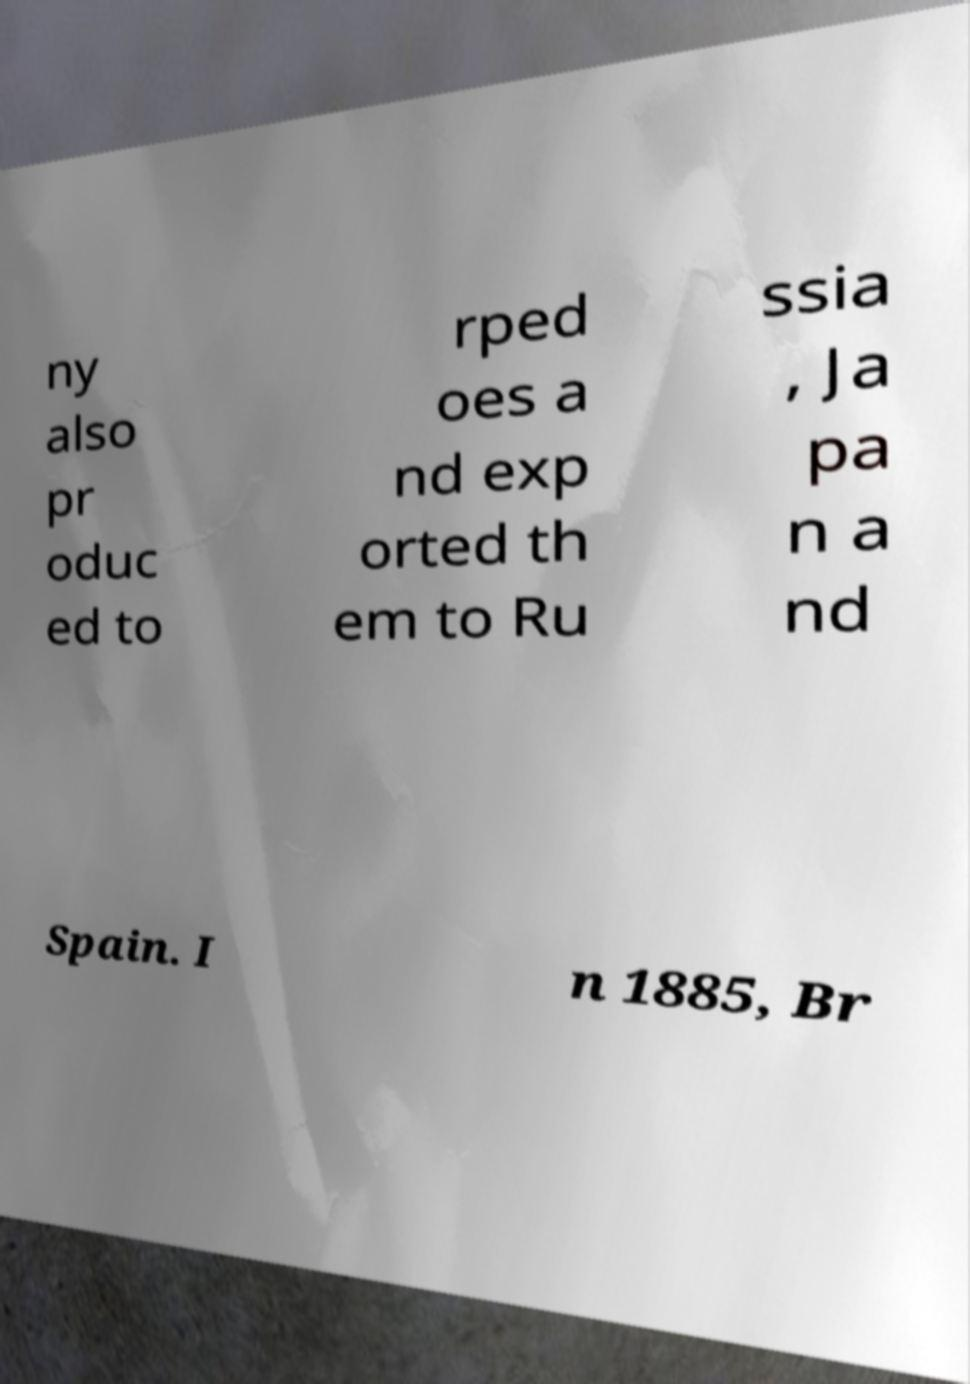What messages or text are displayed in this image? I need them in a readable, typed format. ny also pr oduc ed to rped oes a nd exp orted th em to Ru ssia , Ja pa n a nd Spain. I n 1885, Br 